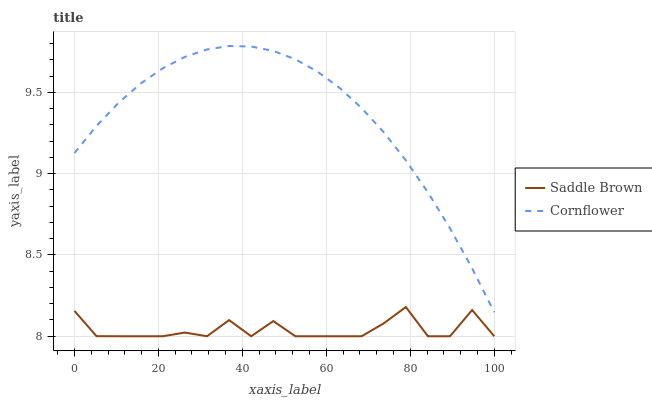Does Saddle Brown have the maximum area under the curve?
Answer yes or no. No. Is Saddle Brown the smoothest?
Answer yes or no. No. Does Saddle Brown have the highest value?
Answer yes or no. No. Is Saddle Brown less than Cornflower?
Answer yes or no. Yes. Is Cornflower greater than Saddle Brown?
Answer yes or no. Yes. Does Saddle Brown intersect Cornflower?
Answer yes or no. No. 